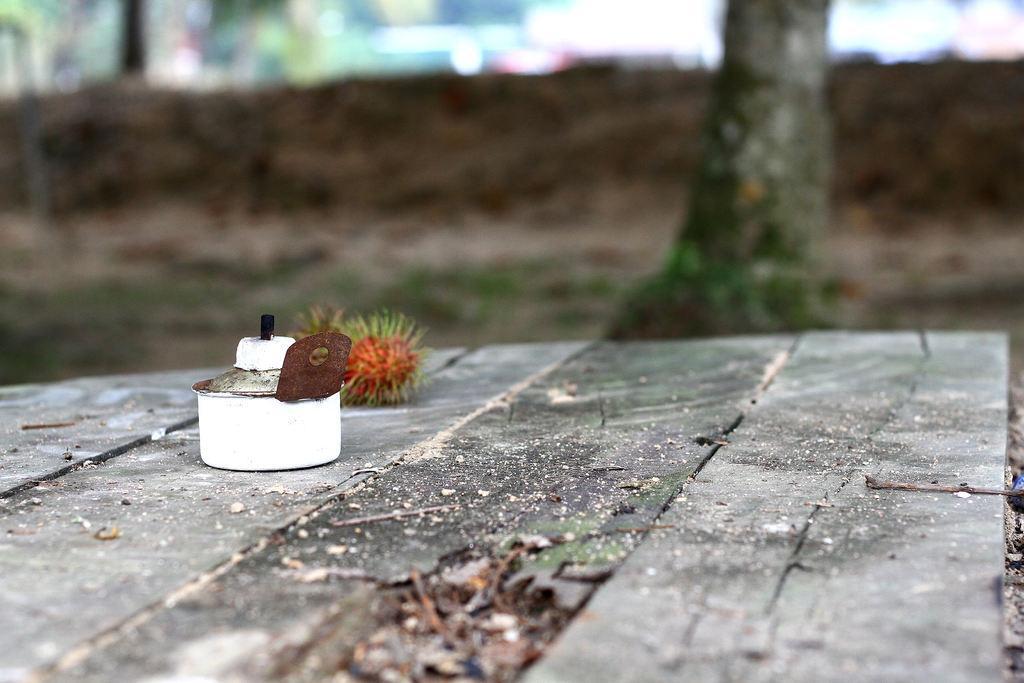Can you describe this image briefly? In this picture there is a white color object on a wooden floor and there is a tree and some other objects in the background. 